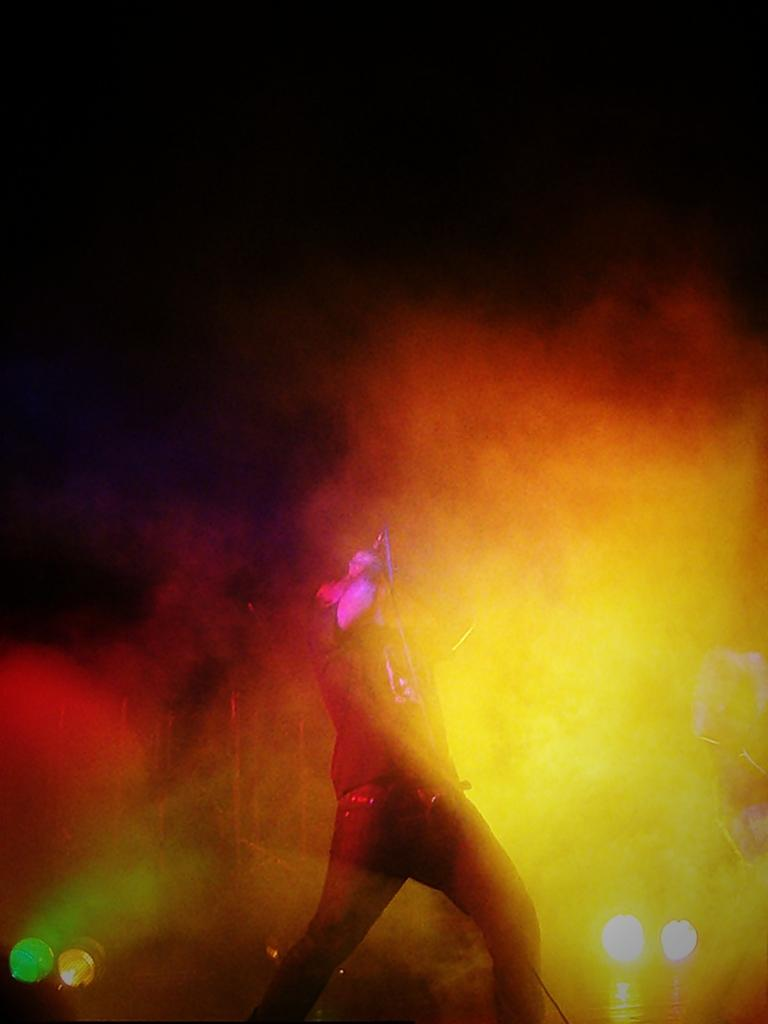What is the person in the image doing? The person is standing in the image and holding a microphone. What might the person be using the microphone for? The person might be using the microphone for speaking or singing. What can be seen in the air in the image? There is smoke in the air in the image. What is at the bottom of the image? There are lights at the bottom of the image. What is the color of the background in the image? The background of the image is black. What type of action does the person take to express hope and love in the image? There is no indication of the person expressing hope or love in the image, as the facts provided do not mention these emotions or actions. 